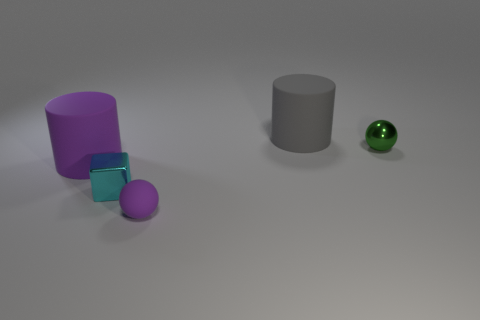Is the number of blocks to the right of the cyan thing less than the number of gray matte things that are in front of the gray cylinder?
Your response must be concise. No. Are the tiny purple thing and the gray object made of the same material?
Your answer should be very brief. Yes. There is a object that is in front of the gray rubber thing and behind the big purple cylinder; how big is it?
Offer a terse response. Small. There is a cyan thing that is the same size as the green sphere; what is its shape?
Keep it short and to the point. Cube. There is a tiny object to the right of the rubber thing that is behind the cylinder that is in front of the large gray rubber cylinder; what is its material?
Ensure brevity in your answer.  Metal. There is a purple rubber object that is in front of the large purple object; does it have the same shape as the metallic thing that is to the right of the purple ball?
Offer a very short reply. Yes. What number of other things are there of the same material as the gray object
Provide a succinct answer. 2. Are the large object that is behind the large purple cylinder and the big cylinder that is to the left of the small cyan cube made of the same material?
Your response must be concise. Yes. What shape is the tiny thing that is the same material as the big gray thing?
Ensure brevity in your answer.  Sphere. Is there any other thing that has the same color as the tiny rubber sphere?
Ensure brevity in your answer.  Yes. 